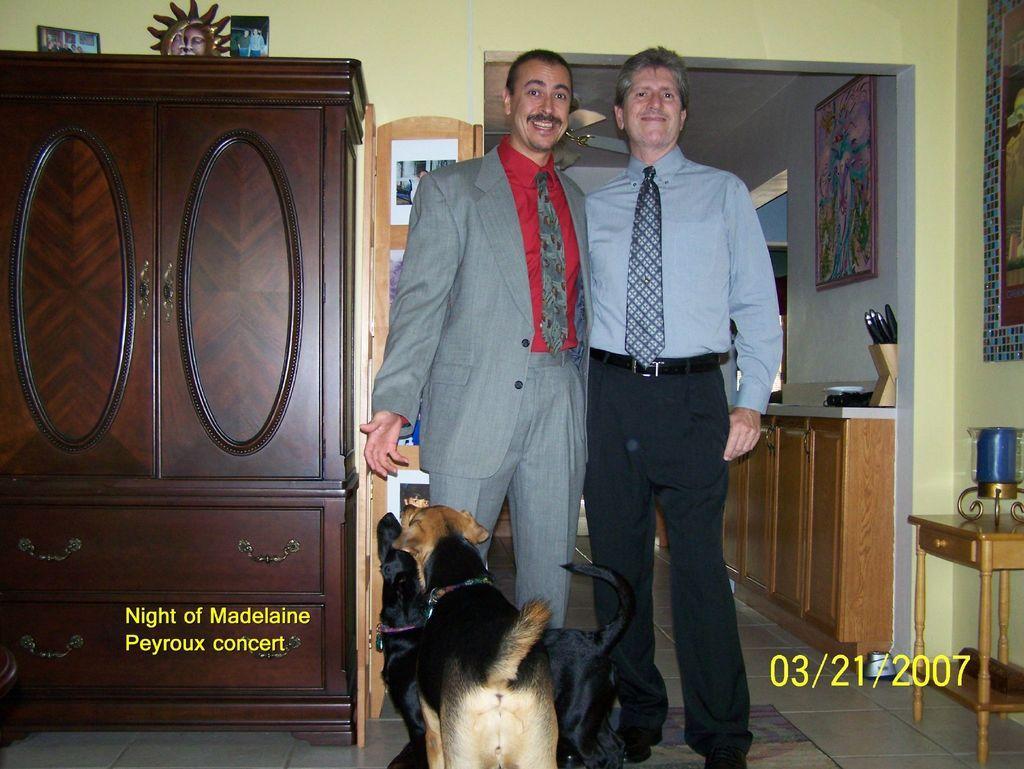Could you give a brief overview of what you see in this image? In this image we can see two persons and dogs in front of them, there is a cupboard with some objects, there is an object with some pictures behind the person on the left side and there is a table with an object, picture frames to the wall and there are few cupboards and objects on the right side of the image and there is a fan to the ceiling in the background. 